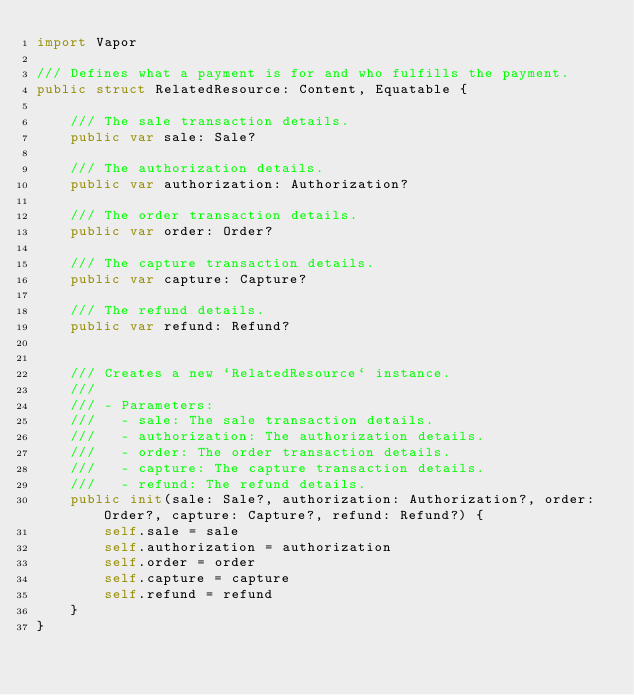<code> <loc_0><loc_0><loc_500><loc_500><_Swift_>import Vapor

/// Defines what a payment is for and who fulfills the payment.
public struct RelatedResource: Content, Equatable {
    
    /// The sale transaction details.
    public var sale: Sale?
    
    /// The authorization details.
    public var authorization: Authorization?
    
    /// The order transaction details.
    public var order: Order?
    
    /// The capture transaction details.
    public var capture: Capture?
    
    /// The refund details.
    public var refund: Refund?
    
    
    /// Creates a new `RelatedResource` instance.
    ///
    /// - Parameters:
    ///   - sale: The sale transaction details.
    ///   - authorization: The authorization details.
    ///   - order: The order transaction details.
    ///   - capture: The capture transaction details.
    ///   - refund: The refund details.
    public init(sale: Sale?, authorization: Authorization?, order: Order?, capture: Capture?, refund: Refund?) {
        self.sale = sale
        self.authorization = authorization
        self.order = order
        self.capture = capture
        self.refund = refund
    }
}
</code> 